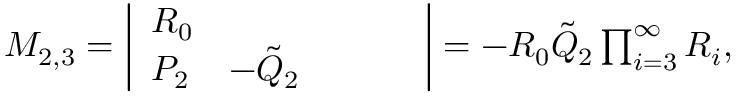Convert formula to latex. <formula><loc_0><loc_0><loc_500><loc_500>\begin{array} { r } { M _ { 2 , 3 } = \left | \begin{array} { l l l l l } { R _ { 0 } } \\ { P _ { 2 } } & { - \tilde { Q } _ { 2 } } \end{array} \right | = - R _ { 0 } \tilde { Q } _ { 2 } \prod _ { i = 3 } ^ { \infty } R _ { i } , } \end{array}</formula> 